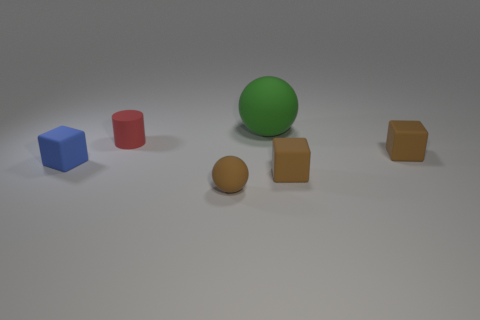Subtract all tiny brown matte blocks. How many blocks are left? 1 Add 1 red things. How many objects exist? 7 Subtract all spheres. How many objects are left? 4 Add 6 big green things. How many big green things are left? 7 Add 6 blue objects. How many blue objects exist? 7 Subtract 0 red blocks. How many objects are left? 6 Subtract all green things. Subtract all gray shiny cylinders. How many objects are left? 5 